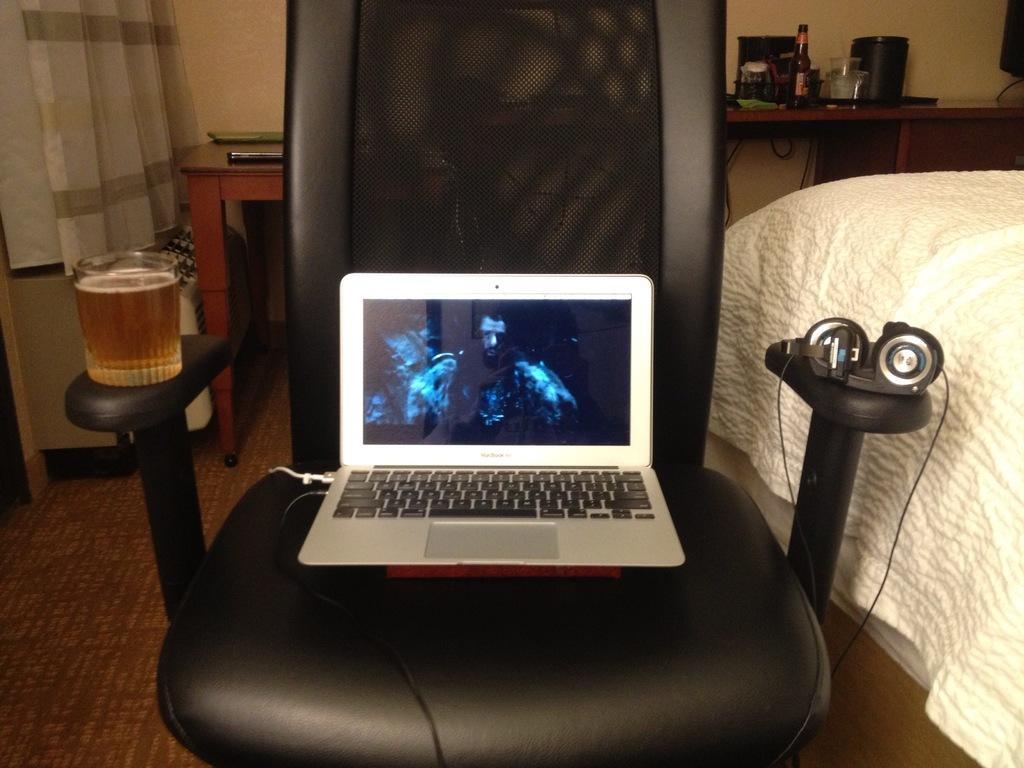Please provide a concise description of this image. In this image i can see a laptop,headphones,wineglass which are on the chair and at the right side of the image there is a bed,bottle and a box. 